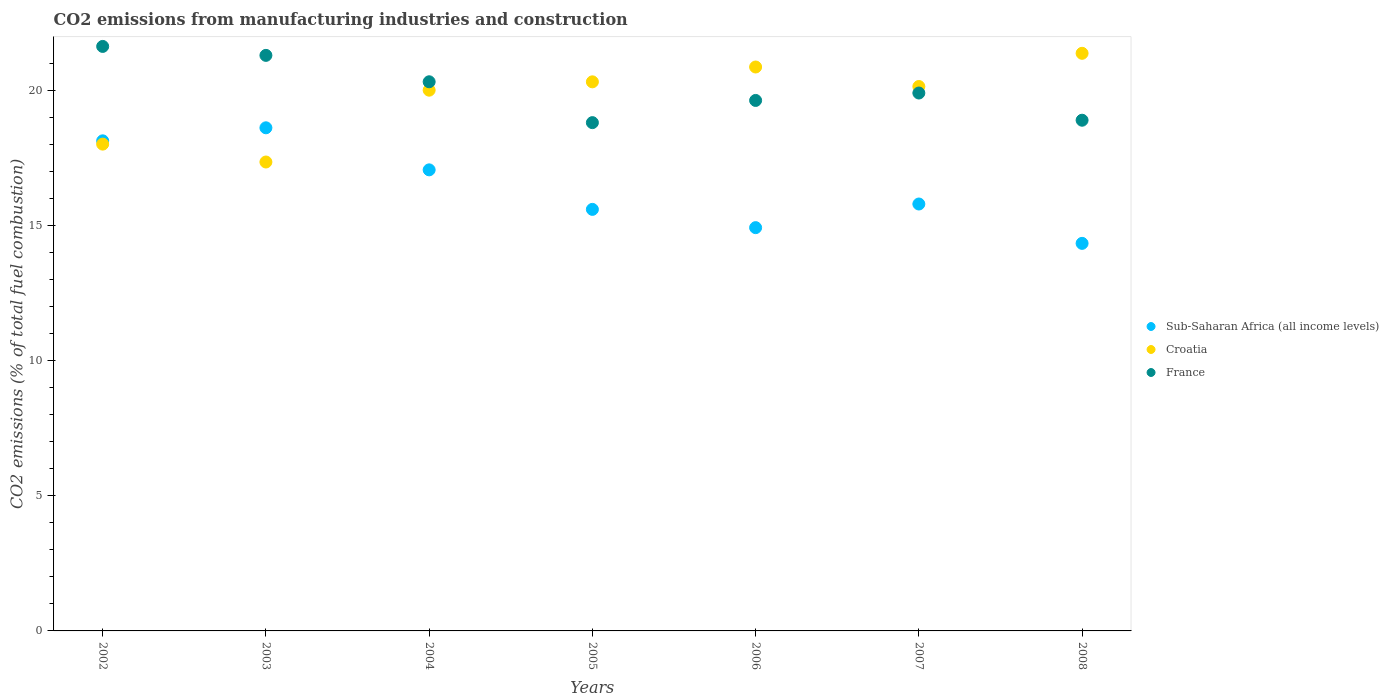Is the number of dotlines equal to the number of legend labels?
Ensure brevity in your answer.  Yes. What is the amount of CO2 emitted in France in 2004?
Your answer should be very brief. 20.31. Across all years, what is the maximum amount of CO2 emitted in France?
Offer a very short reply. 21.62. Across all years, what is the minimum amount of CO2 emitted in Croatia?
Make the answer very short. 17.34. In which year was the amount of CO2 emitted in Croatia maximum?
Offer a very short reply. 2008. In which year was the amount of CO2 emitted in France minimum?
Provide a short and direct response. 2005. What is the total amount of CO2 emitted in Croatia in the graph?
Provide a succinct answer. 138.01. What is the difference between the amount of CO2 emitted in Croatia in 2002 and that in 2007?
Offer a terse response. -2.13. What is the difference between the amount of CO2 emitted in France in 2006 and the amount of CO2 emitted in Sub-Saharan Africa (all income levels) in 2004?
Give a very brief answer. 2.57. What is the average amount of CO2 emitted in France per year?
Offer a terse response. 20.06. In the year 2006, what is the difference between the amount of CO2 emitted in Sub-Saharan Africa (all income levels) and amount of CO2 emitted in Croatia?
Make the answer very short. -5.94. In how many years, is the amount of CO2 emitted in France greater than 8 %?
Make the answer very short. 7. What is the ratio of the amount of CO2 emitted in Croatia in 2002 to that in 2008?
Offer a terse response. 0.84. Is the difference between the amount of CO2 emitted in Sub-Saharan Africa (all income levels) in 2003 and 2004 greater than the difference between the amount of CO2 emitted in Croatia in 2003 and 2004?
Ensure brevity in your answer.  Yes. What is the difference between the highest and the second highest amount of CO2 emitted in Sub-Saharan Africa (all income levels)?
Provide a short and direct response. 0.48. What is the difference between the highest and the lowest amount of CO2 emitted in Sub-Saharan Africa (all income levels)?
Your answer should be compact. 4.27. Does the amount of CO2 emitted in France monotonically increase over the years?
Give a very brief answer. No. Is the amount of CO2 emitted in Sub-Saharan Africa (all income levels) strictly greater than the amount of CO2 emitted in France over the years?
Give a very brief answer. No. How many years are there in the graph?
Offer a very short reply. 7. What is the difference between two consecutive major ticks on the Y-axis?
Give a very brief answer. 5. Does the graph contain any zero values?
Your answer should be compact. No. What is the title of the graph?
Offer a very short reply. CO2 emissions from manufacturing industries and construction. Does "Italy" appear as one of the legend labels in the graph?
Give a very brief answer. No. What is the label or title of the Y-axis?
Provide a short and direct response. CO2 emissions (% of total fuel combustion). What is the CO2 emissions (% of total fuel combustion) in Sub-Saharan Africa (all income levels) in 2002?
Make the answer very short. 18.13. What is the CO2 emissions (% of total fuel combustion) of Croatia in 2002?
Your answer should be very brief. 18.01. What is the CO2 emissions (% of total fuel combustion) of France in 2002?
Offer a very short reply. 21.62. What is the CO2 emissions (% of total fuel combustion) of Sub-Saharan Africa (all income levels) in 2003?
Your response must be concise. 18.61. What is the CO2 emissions (% of total fuel combustion) of Croatia in 2003?
Ensure brevity in your answer.  17.34. What is the CO2 emissions (% of total fuel combustion) of France in 2003?
Your answer should be compact. 21.29. What is the CO2 emissions (% of total fuel combustion) in Sub-Saharan Africa (all income levels) in 2004?
Provide a succinct answer. 17.05. What is the CO2 emissions (% of total fuel combustion) of France in 2004?
Your answer should be compact. 20.31. What is the CO2 emissions (% of total fuel combustion) in Sub-Saharan Africa (all income levels) in 2005?
Make the answer very short. 15.59. What is the CO2 emissions (% of total fuel combustion) in Croatia in 2005?
Your answer should be very brief. 20.31. What is the CO2 emissions (% of total fuel combustion) of France in 2005?
Your response must be concise. 18.8. What is the CO2 emissions (% of total fuel combustion) of Sub-Saharan Africa (all income levels) in 2006?
Your response must be concise. 14.92. What is the CO2 emissions (% of total fuel combustion) of Croatia in 2006?
Keep it short and to the point. 20.86. What is the CO2 emissions (% of total fuel combustion) of France in 2006?
Provide a short and direct response. 19.62. What is the CO2 emissions (% of total fuel combustion) in Sub-Saharan Africa (all income levels) in 2007?
Offer a very short reply. 15.79. What is the CO2 emissions (% of total fuel combustion) in Croatia in 2007?
Offer a very short reply. 20.14. What is the CO2 emissions (% of total fuel combustion) in France in 2007?
Offer a very short reply. 19.89. What is the CO2 emissions (% of total fuel combustion) of Sub-Saharan Africa (all income levels) in 2008?
Your response must be concise. 14.33. What is the CO2 emissions (% of total fuel combustion) of Croatia in 2008?
Provide a succinct answer. 21.36. What is the CO2 emissions (% of total fuel combustion) of France in 2008?
Provide a succinct answer. 18.89. Across all years, what is the maximum CO2 emissions (% of total fuel combustion) of Sub-Saharan Africa (all income levels)?
Keep it short and to the point. 18.61. Across all years, what is the maximum CO2 emissions (% of total fuel combustion) of Croatia?
Ensure brevity in your answer.  21.36. Across all years, what is the maximum CO2 emissions (% of total fuel combustion) of France?
Give a very brief answer. 21.62. Across all years, what is the minimum CO2 emissions (% of total fuel combustion) of Sub-Saharan Africa (all income levels)?
Give a very brief answer. 14.33. Across all years, what is the minimum CO2 emissions (% of total fuel combustion) of Croatia?
Provide a succinct answer. 17.34. Across all years, what is the minimum CO2 emissions (% of total fuel combustion) in France?
Offer a very short reply. 18.8. What is the total CO2 emissions (% of total fuel combustion) in Sub-Saharan Africa (all income levels) in the graph?
Your answer should be very brief. 114.42. What is the total CO2 emissions (% of total fuel combustion) in Croatia in the graph?
Keep it short and to the point. 138.01. What is the total CO2 emissions (% of total fuel combustion) in France in the graph?
Give a very brief answer. 140.42. What is the difference between the CO2 emissions (% of total fuel combustion) of Sub-Saharan Africa (all income levels) in 2002 and that in 2003?
Keep it short and to the point. -0.48. What is the difference between the CO2 emissions (% of total fuel combustion) of Croatia in 2002 and that in 2003?
Your answer should be very brief. 0.66. What is the difference between the CO2 emissions (% of total fuel combustion) in France in 2002 and that in 2003?
Offer a very short reply. 0.33. What is the difference between the CO2 emissions (% of total fuel combustion) in Sub-Saharan Africa (all income levels) in 2002 and that in 2004?
Provide a succinct answer. 1.07. What is the difference between the CO2 emissions (% of total fuel combustion) in Croatia in 2002 and that in 2004?
Keep it short and to the point. -1.99. What is the difference between the CO2 emissions (% of total fuel combustion) in France in 2002 and that in 2004?
Ensure brevity in your answer.  1.31. What is the difference between the CO2 emissions (% of total fuel combustion) of Sub-Saharan Africa (all income levels) in 2002 and that in 2005?
Give a very brief answer. 2.54. What is the difference between the CO2 emissions (% of total fuel combustion) in Croatia in 2002 and that in 2005?
Your answer should be compact. -2.3. What is the difference between the CO2 emissions (% of total fuel combustion) in France in 2002 and that in 2005?
Keep it short and to the point. 2.82. What is the difference between the CO2 emissions (% of total fuel combustion) of Sub-Saharan Africa (all income levels) in 2002 and that in 2006?
Keep it short and to the point. 3.21. What is the difference between the CO2 emissions (% of total fuel combustion) in Croatia in 2002 and that in 2006?
Make the answer very short. -2.85. What is the difference between the CO2 emissions (% of total fuel combustion) of France in 2002 and that in 2006?
Provide a short and direct response. 2. What is the difference between the CO2 emissions (% of total fuel combustion) of Sub-Saharan Africa (all income levels) in 2002 and that in 2007?
Your answer should be compact. 2.34. What is the difference between the CO2 emissions (% of total fuel combustion) of Croatia in 2002 and that in 2007?
Offer a very short reply. -2.13. What is the difference between the CO2 emissions (% of total fuel combustion) of France in 2002 and that in 2007?
Keep it short and to the point. 1.72. What is the difference between the CO2 emissions (% of total fuel combustion) of Sub-Saharan Africa (all income levels) in 2002 and that in 2008?
Your answer should be very brief. 3.79. What is the difference between the CO2 emissions (% of total fuel combustion) of Croatia in 2002 and that in 2008?
Provide a short and direct response. -3.36. What is the difference between the CO2 emissions (% of total fuel combustion) in France in 2002 and that in 2008?
Your response must be concise. 2.73. What is the difference between the CO2 emissions (% of total fuel combustion) in Sub-Saharan Africa (all income levels) in 2003 and that in 2004?
Your answer should be very brief. 1.56. What is the difference between the CO2 emissions (% of total fuel combustion) in Croatia in 2003 and that in 2004?
Make the answer very short. -2.66. What is the difference between the CO2 emissions (% of total fuel combustion) in France in 2003 and that in 2004?
Make the answer very short. 0.98. What is the difference between the CO2 emissions (% of total fuel combustion) of Sub-Saharan Africa (all income levels) in 2003 and that in 2005?
Your answer should be compact. 3.02. What is the difference between the CO2 emissions (% of total fuel combustion) of Croatia in 2003 and that in 2005?
Offer a very short reply. -2.97. What is the difference between the CO2 emissions (% of total fuel combustion) in France in 2003 and that in 2005?
Provide a succinct answer. 2.49. What is the difference between the CO2 emissions (% of total fuel combustion) of Sub-Saharan Africa (all income levels) in 2003 and that in 2006?
Ensure brevity in your answer.  3.69. What is the difference between the CO2 emissions (% of total fuel combustion) in Croatia in 2003 and that in 2006?
Offer a very short reply. -3.51. What is the difference between the CO2 emissions (% of total fuel combustion) of France in 2003 and that in 2006?
Ensure brevity in your answer.  1.67. What is the difference between the CO2 emissions (% of total fuel combustion) of Sub-Saharan Africa (all income levels) in 2003 and that in 2007?
Offer a terse response. 2.82. What is the difference between the CO2 emissions (% of total fuel combustion) of Croatia in 2003 and that in 2007?
Offer a very short reply. -2.79. What is the difference between the CO2 emissions (% of total fuel combustion) in France in 2003 and that in 2007?
Ensure brevity in your answer.  1.39. What is the difference between the CO2 emissions (% of total fuel combustion) in Sub-Saharan Africa (all income levels) in 2003 and that in 2008?
Give a very brief answer. 4.27. What is the difference between the CO2 emissions (% of total fuel combustion) of Croatia in 2003 and that in 2008?
Your answer should be very brief. -4.02. What is the difference between the CO2 emissions (% of total fuel combustion) of France in 2003 and that in 2008?
Give a very brief answer. 2.4. What is the difference between the CO2 emissions (% of total fuel combustion) of Sub-Saharan Africa (all income levels) in 2004 and that in 2005?
Provide a succinct answer. 1.46. What is the difference between the CO2 emissions (% of total fuel combustion) in Croatia in 2004 and that in 2005?
Your answer should be compact. -0.31. What is the difference between the CO2 emissions (% of total fuel combustion) in France in 2004 and that in 2005?
Your answer should be very brief. 1.51. What is the difference between the CO2 emissions (% of total fuel combustion) in Sub-Saharan Africa (all income levels) in 2004 and that in 2006?
Your answer should be compact. 2.14. What is the difference between the CO2 emissions (% of total fuel combustion) in Croatia in 2004 and that in 2006?
Your answer should be very brief. -0.86. What is the difference between the CO2 emissions (% of total fuel combustion) in France in 2004 and that in 2006?
Make the answer very short. 0.69. What is the difference between the CO2 emissions (% of total fuel combustion) in Sub-Saharan Africa (all income levels) in 2004 and that in 2007?
Your response must be concise. 1.26. What is the difference between the CO2 emissions (% of total fuel combustion) in Croatia in 2004 and that in 2007?
Provide a succinct answer. -0.14. What is the difference between the CO2 emissions (% of total fuel combustion) in France in 2004 and that in 2007?
Give a very brief answer. 0.42. What is the difference between the CO2 emissions (% of total fuel combustion) in Sub-Saharan Africa (all income levels) in 2004 and that in 2008?
Ensure brevity in your answer.  2.72. What is the difference between the CO2 emissions (% of total fuel combustion) of Croatia in 2004 and that in 2008?
Provide a succinct answer. -1.36. What is the difference between the CO2 emissions (% of total fuel combustion) in France in 2004 and that in 2008?
Give a very brief answer. 1.42. What is the difference between the CO2 emissions (% of total fuel combustion) of Sub-Saharan Africa (all income levels) in 2005 and that in 2006?
Provide a short and direct response. 0.68. What is the difference between the CO2 emissions (% of total fuel combustion) of Croatia in 2005 and that in 2006?
Provide a succinct answer. -0.55. What is the difference between the CO2 emissions (% of total fuel combustion) in France in 2005 and that in 2006?
Your answer should be very brief. -0.82. What is the difference between the CO2 emissions (% of total fuel combustion) in Sub-Saharan Africa (all income levels) in 2005 and that in 2007?
Offer a very short reply. -0.2. What is the difference between the CO2 emissions (% of total fuel combustion) in Croatia in 2005 and that in 2007?
Your answer should be compact. 0.17. What is the difference between the CO2 emissions (% of total fuel combustion) of France in 2005 and that in 2007?
Ensure brevity in your answer.  -1.1. What is the difference between the CO2 emissions (% of total fuel combustion) of Sub-Saharan Africa (all income levels) in 2005 and that in 2008?
Keep it short and to the point. 1.26. What is the difference between the CO2 emissions (% of total fuel combustion) of Croatia in 2005 and that in 2008?
Make the answer very short. -1.06. What is the difference between the CO2 emissions (% of total fuel combustion) in France in 2005 and that in 2008?
Your answer should be compact. -0.09. What is the difference between the CO2 emissions (% of total fuel combustion) of Sub-Saharan Africa (all income levels) in 2006 and that in 2007?
Offer a very short reply. -0.87. What is the difference between the CO2 emissions (% of total fuel combustion) in Croatia in 2006 and that in 2007?
Provide a short and direct response. 0.72. What is the difference between the CO2 emissions (% of total fuel combustion) in France in 2006 and that in 2007?
Your answer should be very brief. -0.27. What is the difference between the CO2 emissions (% of total fuel combustion) in Sub-Saharan Africa (all income levels) in 2006 and that in 2008?
Offer a very short reply. 0.58. What is the difference between the CO2 emissions (% of total fuel combustion) in Croatia in 2006 and that in 2008?
Give a very brief answer. -0.51. What is the difference between the CO2 emissions (% of total fuel combustion) in France in 2006 and that in 2008?
Your response must be concise. 0.73. What is the difference between the CO2 emissions (% of total fuel combustion) of Sub-Saharan Africa (all income levels) in 2007 and that in 2008?
Provide a succinct answer. 1.46. What is the difference between the CO2 emissions (% of total fuel combustion) in Croatia in 2007 and that in 2008?
Your answer should be compact. -1.23. What is the difference between the CO2 emissions (% of total fuel combustion) of France in 2007 and that in 2008?
Offer a terse response. 1.01. What is the difference between the CO2 emissions (% of total fuel combustion) of Sub-Saharan Africa (all income levels) in 2002 and the CO2 emissions (% of total fuel combustion) of Croatia in 2003?
Your answer should be very brief. 0.78. What is the difference between the CO2 emissions (% of total fuel combustion) in Sub-Saharan Africa (all income levels) in 2002 and the CO2 emissions (% of total fuel combustion) in France in 2003?
Offer a very short reply. -3.16. What is the difference between the CO2 emissions (% of total fuel combustion) in Croatia in 2002 and the CO2 emissions (% of total fuel combustion) in France in 2003?
Your answer should be compact. -3.28. What is the difference between the CO2 emissions (% of total fuel combustion) in Sub-Saharan Africa (all income levels) in 2002 and the CO2 emissions (% of total fuel combustion) in Croatia in 2004?
Your response must be concise. -1.87. What is the difference between the CO2 emissions (% of total fuel combustion) in Sub-Saharan Africa (all income levels) in 2002 and the CO2 emissions (% of total fuel combustion) in France in 2004?
Offer a terse response. -2.18. What is the difference between the CO2 emissions (% of total fuel combustion) in Croatia in 2002 and the CO2 emissions (% of total fuel combustion) in France in 2004?
Offer a very short reply. -2.31. What is the difference between the CO2 emissions (% of total fuel combustion) of Sub-Saharan Africa (all income levels) in 2002 and the CO2 emissions (% of total fuel combustion) of Croatia in 2005?
Give a very brief answer. -2.18. What is the difference between the CO2 emissions (% of total fuel combustion) in Sub-Saharan Africa (all income levels) in 2002 and the CO2 emissions (% of total fuel combustion) in France in 2005?
Your answer should be compact. -0.67. What is the difference between the CO2 emissions (% of total fuel combustion) of Croatia in 2002 and the CO2 emissions (% of total fuel combustion) of France in 2005?
Provide a short and direct response. -0.79. What is the difference between the CO2 emissions (% of total fuel combustion) in Sub-Saharan Africa (all income levels) in 2002 and the CO2 emissions (% of total fuel combustion) in Croatia in 2006?
Offer a very short reply. -2.73. What is the difference between the CO2 emissions (% of total fuel combustion) of Sub-Saharan Africa (all income levels) in 2002 and the CO2 emissions (% of total fuel combustion) of France in 2006?
Provide a succinct answer. -1.49. What is the difference between the CO2 emissions (% of total fuel combustion) of Croatia in 2002 and the CO2 emissions (% of total fuel combustion) of France in 2006?
Offer a terse response. -1.62. What is the difference between the CO2 emissions (% of total fuel combustion) in Sub-Saharan Africa (all income levels) in 2002 and the CO2 emissions (% of total fuel combustion) in Croatia in 2007?
Keep it short and to the point. -2.01. What is the difference between the CO2 emissions (% of total fuel combustion) of Sub-Saharan Africa (all income levels) in 2002 and the CO2 emissions (% of total fuel combustion) of France in 2007?
Keep it short and to the point. -1.77. What is the difference between the CO2 emissions (% of total fuel combustion) of Croatia in 2002 and the CO2 emissions (% of total fuel combustion) of France in 2007?
Your answer should be very brief. -1.89. What is the difference between the CO2 emissions (% of total fuel combustion) in Sub-Saharan Africa (all income levels) in 2002 and the CO2 emissions (% of total fuel combustion) in Croatia in 2008?
Ensure brevity in your answer.  -3.24. What is the difference between the CO2 emissions (% of total fuel combustion) in Sub-Saharan Africa (all income levels) in 2002 and the CO2 emissions (% of total fuel combustion) in France in 2008?
Offer a very short reply. -0.76. What is the difference between the CO2 emissions (% of total fuel combustion) of Croatia in 2002 and the CO2 emissions (% of total fuel combustion) of France in 2008?
Offer a terse response. -0.88. What is the difference between the CO2 emissions (% of total fuel combustion) in Sub-Saharan Africa (all income levels) in 2003 and the CO2 emissions (% of total fuel combustion) in Croatia in 2004?
Provide a succinct answer. -1.39. What is the difference between the CO2 emissions (% of total fuel combustion) of Sub-Saharan Africa (all income levels) in 2003 and the CO2 emissions (% of total fuel combustion) of France in 2004?
Offer a terse response. -1.7. What is the difference between the CO2 emissions (% of total fuel combustion) in Croatia in 2003 and the CO2 emissions (% of total fuel combustion) in France in 2004?
Make the answer very short. -2.97. What is the difference between the CO2 emissions (% of total fuel combustion) of Sub-Saharan Africa (all income levels) in 2003 and the CO2 emissions (% of total fuel combustion) of France in 2005?
Make the answer very short. -0.19. What is the difference between the CO2 emissions (% of total fuel combustion) in Croatia in 2003 and the CO2 emissions (% of total fuel combustion) in France in 2005?
Give a very brief answer. -1.46. What is the difference between the CO2 emissions (% of total fuel combustion) in Sub-Saharan Africa (all income levels) in 2003 and the CO2 emissions (% of total fuel combustion) in Croatia in 2006?
Keep it short and to the point. -2.25. What is the difference between the CO2 emissions (% of total fuel combustion) in Sub-Saharan Africa (all income levels) in 2003 and the CO2 emissions (% of total fuel combustion) in France in 2006?
Ensure brevity in your answer.  -1.01. What is the difference between the CO2 emissions (% of total fuel combustion) in Croatia in 2003 and the CO2 emissions (% of total fuel combustion) in France in 2006?
Your response must be concise. -2.28. What is the difference between the CO2 emissions (% of total fuel combustion) of Sub-Saharan Africa (all income levels) in 2003 and the CO2 emissions (% of total fuel combustion) of Croatia in 2007?
Provide a succinct answer. -1.53. What is the difference between the CO2 emissions (% of total fuel combustion) of Sub-Saharan Africa (all income levels) in 2003 and the CO2 emissions (% of total fuel combustion) of France in 2007?
Provide a short and direct response. -1.29. What is the difference between the CO2 emissions (% of total fuel combustion) in Croatia in 2003 and the CO2 emissions (% of total fuel combustion) in France in 2007?
Provide a succinct answer. -2.55. What is the difference between the CO2 emissions (% of total fuel combustion) in Sub-Saharan Africa (all income levels) in 2003 and the CO2 emissions (% of total fuel combustion) in Croatia in 2008?
Keep it short and to the point. -2.76. What is the difference between the CO2 emissions (% of total fuel combustion) in Sub-Saharan Africa (all income levels) in 2003 and the CO2 emissions (% of total fuel combustion) in France in 2008?
Your response must be concise. -0.28. What is the difference between the CO2 emissions (% of total fuel combustion) in Croatia in 2003 and the CO2 emissions (% of total fuel combustion) in France in 2008?
Your answer should be compact. -1.55. What is the difference between the CO2 emissions (% of total fuel combustion) in Sub-Saharan Africa (all income levels) in 2004 and the CO2 emissions (% of total fuel combustion) in Croatia in 2005?
Ensure brevity in your answer.  -3.26. What is the difference between the CO2 emissions (% of total fuel combustion) of Sub-Saharan Africa (all income levels) in 2004 and the CO2 emissions (% of total fuel combustion) of France in 2005?
Give a very brief answer. -1.75. What is the difference between the CO2 emissions (% of total fuel combustion) in Croatia in 2004 and the CO2 emissions (% of total fuel combustion) in France in 2005?
Provide a succinct answer. 1.2. What is the difference between the CO2 emissions (% of total fuel combustion) in Sub-Saharan Africa (all income levels) in 2004 and the CO2 emissions (% of total fuel combustion) in Croatia in 2006?
Ensure brevity in your answer.  -3.8. What is the difference between the CO2 emissions (% of total fuel combustion) of Sub-Saharan Africa (all income levels) in 2004 and the CO2 emissions (% of total fuel combustion) of France in 2006?
Give a very brief answer. -2.57. What is the difference between the CO2 emissions (% of total fuel combustion) of Croatia in 2004 and the CO2 emissions (% of total fuel combustion) of France in 2006?
Your response must be concise. 0.38. What is the difference between the CO2 emissions (% of total fuel combustion) in Sub-Saharan Africa (all income levels) in 2004 and the CO2 emissions (% of total fuel combustion) in Croatia in 2007?
Offer a terse response. -3.08. What is the difference between the CO2 emissions (% of total fuel combustion) of Sub-Saharan Africa (all income levels) in 2004 and the CO2 emissions (% of total fuel combustion) of France in 2007?
Offer a terse response. -2.84. What is the difference between the CO2 emissions (% of total fuel combustion) of Croatia in 2004 and the CO2 emissions (% of total fuel combustion) of France in 2007?
Ensure brevity in your answer.  0.11. What is the difference between the CO2 emissions (% of total fuel combustion) in Sub-Saharan Africa (all income levels) in 2004 and the CO2 emissions (% of total fuel combustion) in Croatia in 2008?
Provide a short and direct response. -4.31. What is the difference between the CO2 emissions (% of total fuel combustion) of Sub-Saharan Africa (all income levels) in 2004 and the CO2 emissions (% of total fuel combustion) of France in 2008?
Offer a very short reply. -1.84. What is the difference between the CO2 emissions (% of total fuel combustion) of Croatia in 2004 and the CO2 emissions (% of total fuel combustion) of France in 2008?
Keep it short and to the point. 1.11. What is the difference between the CO2 emissions (% of total fuel combustion) in Sub-Saharan Africa (all income levels) in 2005 and the CO2 emissions (% of total fuel combustion) in Croatia in 2006?
Your answer should be compact. -5.27. What is the difference between the CO2 emissions (% of total fuel combustion) in Sub-Saharan Africa (all income levels) in 2005 and the CO2 emissions (% of total fuel combustion) in France in 2006?
Offer a very short reply. -4.03. What is the difference between the CO2 emissions (% of total fuel combustion) of Croatia in 2005 and the CO2 emissions (% of total fuel combustion) of France in 2006?
Offer a terse response. 0.69. What is the difference between the CO2 emissions (% of total fuel combustion) in Sub-Saharan Africa (all income levels) in 2005 and the CO2 emissions (% of total fuel combustion) in Croatia in 2007?
Keep it short and to the point. -4.54. What is the difference between the CO2 emissions (% of total fuel combustion) in Sub-Saharan Africa (all income levels) in 2005 and the CO2 emissions (% of total fuel combustion) in France in 2007?
Ensure brevity in your answer.  -4.3. What is the difference between the CO2 emissions (% of total fuel combustion) in Croatia in 2005 and the CO2 emissions (% of total fuel combustion) in France in 2007?
Offer a terse response. 0.41. What is the difference between the CO2 emissions (% of total fuel combustion) of Sub-Saharan Africa (all income levels) in 2005 and the CO2 emissions (% of total fuel combustion) of Croatia in 2008?
Give a very brief answer. -5.77. What is the difference between the CO2 emissions (% of total fuel combustion) in Sub-Saharan Africa (all income levels) in 2005 and the CO2 emissions (% of total fuel combustion) in France in 2008?
Your answer should be compact. -3.3. What is the difference between the CO2 emissions (% of total fuel combustion) of Croatia in 2005 and the CO2 emissions (% of total fuel combustion) of France in 2008?
Give a very brief answer. 1.42. What is the difference between the CO2 emissions (% of total fuel combustion) of Sub-Saharan Africa (all income levels) in 2006 and the CO2 emissions (% of total fuel combustion) of Croatia in 2007?
Ensure brevity in your answer.  -5.22. What is the difference between the CO2 emissions (% of total fuel combustion) in Sub-Saharan Africa (all income levels) in 2006 and the CO2 emissions (% of total fuel combustion) in France in 2007?
Ensure brevity in your answer.  -4.98. What is the difference between the CO2 emissions (% of total fuel combustion) of Croatia in 2006 and the CO2 emissions (% of total fuel combustion) of France in 2007?
Keep it short and to the point. 0.96. What is the difference between the CO2 emissions (% of total fuel combustion) in Sub-Saharan Africa (all income levels) in 2006 and the CO2 emissions (% of total fuel combustion) in Croatia in 2008?
Make the answer very short. -6.45. What is the difference between the CO2 emissions (% of total fuel combustion) in Sub-Saharan Africa (all income levels) in 2006 and the CO2 emissions (% of total fuel combustion) in France in 2008?
Offer a very short reply. -3.97. What is the difference between the CO2 emissions (% of total fuel combustion) of Croatia in 2006 and the CO2 emissions (% of total fuel combustion) of France in 2008?
Offer a very short reply. 1.97. What is the difference between the CO2 emissions (% of total fuel combustion) in Sub-Saharan Africa (all income levels) in 2007 and the CO2 emissions (% of total fuel combustion) in Croatia in 2008?
Ensure brevity in your answer.  -5.57. What is the difference between the CO2 emissions (% of total fuel combustion) in Sub-Saharan Africa (all income levels) in 2007 and the CO2 emissions (% of total fuel combustion) in France in 2008?
Offer a very short reply. -3.1. What is the difference between the CO2 emissions (% of total fuel combustion) of Croatia in 2007 and the CO2 emissions (% of total fuel combustion) of France in 2008?
Provide a short and direct response. 1.25. What is the average CO2 emissions (% of total fuel combustion) of Sub-Saharan Africa (all income levels) per year?
Your answer should be compact. 16.35. What is the average CO2 emissions (% of total fuel combustion) in Croatia per year?
Provide a short and direct response. 19.72. What is the average CO2 emissions (% of total fuel combustion) of France per year?
Provide a short and direct response. 20.06. In the year 2002, what is the difference between the CO2 emissions (% of total fuel combustion) of Sub-Saharan Africa (all income levels) and CO2 emissions (% of total fuel combustion) of Croatia?
Offer a very short reply. 0.12. In the year 2002, what is the difference between the CO2 emissions (% of total fuel combustion) in Sub-Saharan Africa (all income levels) and CO2 emissions (% of total fuel combustion) in France?
Make the answer very short. -3.49. In the year 2002, what is the difference between the CO2 emissions (% of total fuel combustion) in Croatia and CO2 emissions (% of total fuel combustion) in France?
Give a very brief answer. -3.61. In the year 2003, what is the difference between the CO2 emissions (% of total fuel combustion) of Sub-Saharan Africa (all income levels) and CO2 emissions (% of total fuel combustion) of Croatia?
Your answer should be very brief. 1.27. In the year 2003, what is the difference between the CO2 emissions (% of total fuel combustion) in Sub-Saharan Africa (all income levels) and CO2 emissions (% of total fuel combustion) in France?
Make the answer very short. -2.68. In the year 2003, what is the difference between the CO2 emissions (% of total fuel combustion) of Croatia and CO2 emissions (% of total fuel combustion) of France?
Provide a succinct answer. -3.94. In the year 2004, what is the difference between the CO2 emissions (% of total fuel combustion) in Sub-Saharan Africa (all income levels) and CO2 emissions (% of total fuel combustion) in Croatia?
Your answer should be compact. -2.95. In the year 2004, what is the difference between the CO2 emissions (% of total fuel combustion) in Sub-Saharan Africa (all income levels) and CO2 emissions (% of total fuel combustion) in France?
Ensure brevity in your answer.  -3.26. In the year 2004, what is the difference between the CO2 emissions (% of total fuel combustion) in Croatia and CO2 emissions (% of total fuel combustion) in France?
Make the answer very short. -0.31. In the year 2005, what is the difference between the CO2 emissions (% of total fuel combustion) of Sub-Saharan Africa (all income levels) and CO2 emissions (% of total fuel combustion) of Croatia?
Provide a succinct answer. -4.72. In the year 2005, what is the difference between the CO2 emissions (% of total fuel combustion) of Sub-Saharan Africa (all income levels) and CO2 emissions (% of total fuel combustion) of France?
Offer a very short reply. -3.21. In the year 2005, what is the difference between the CO2 emissions (% of total fuel combustion) in Croatia and CO2 emissions (% of total fuel combustion) in France?
Offer a very short reply. 1.51. In the year 2006, what is the difference between the CO2 emissions (% of total fuel combustion) in Sub-Saharan Africa (all income levels) and CO2 emissions (% of total fuel combustion) in Croatia?
Make the answer very short. -5.94. In the year 2006, what is the difference between the CO2 emissions (% of total fuel combustion) in Sub-Saharan Africa (all income levels) and CO2 emissions (% of total fuel combustion) in France?
Ensure brevity in your answer.  -4.71. In the year 2006, what is the difference between the CO2 emissions (% of total fuel combustion) in Croatia and CO2 emissions (% of total fuel combustion) in France?
Your response must be concise. 1.24. In the year 2007, what is the difference between the CO2 emissions (% of total fuel combustion) in Sub-Saharan Africa (all income levels) and CO2 emissions (% of total fuel combustion) in Croatia?
Your response must be concise. -4.35. In the year 2007, what is the difference between the CO2 emissions (% of total fuel combustion) in Sub-Saharan Africa (all income levels) and CO2 emissions (% of total fuel combustion) in France?
Offer a very short reply. -4.1. In the year 2007, what is the difference between the CO2 emissions (% of total fuel combustion) of Croatia and CO2 emissions (% of total fuel combustion) of France?
Your answer should be compact. 0.24. In the year 2008, what is the difference between the CO2 emissions (% of total fuel combustion) in Sub-Saharan Africa (all income levels) and CO2 emissions (% of total fuel combustion) in Croatia?
Your answer should be very brief. -7.03. In the year 2008, what is the difference between the CO2 emissions (% of total fuel combustion) in Sub-Saharan Africa (all income levels) and CO2 emissions (% of total fuel combustion) in France?
Make the answer very short. -4.55. In the year 2008, what is the difference between the CO2 emissions (% of total fuel combustion) in Croatia and CO2 emissions (% of total fuel combustion) in France?
Provide a succinct answer. 2.47. What is the ratio of the CO2 emissions (% of total fuel combustion) in Sub-Saharan Africa (all income levels) in 2002 to that in 2003?
Offer a terse response. 0.97. What is the ratio of the CO2 emissions (% of total fuel combustion) in Croatia in 2002 to that in 2003?
Your answer should be very brief. 1.04. What is the ratio of the CO2 emissions (% of total fuel combustion) of France in 2002 to that in 2003?
Your answer should be very brief. 1.02. What is the ratio of the CO2 emissions (% of total fuel combustion) of Sub-Saharan Africa (all income levels) in 2002 to that in 2004?
Your answer should be very brief. 1.06. What is the ratio of the CO2 emissions (% of total fuel combustion) of Croatia in 2002 to that in 2004?
Provide a succinct answer. 0.9. What is the ratio of the CO2 emissions (% of total fuel combustion) of France in 2002 to that in 2004?
Provide a short and direct response. 1.06. What is the ratio of the CO2 emissions (% of total fuel combustion) of Sub-Saharan Africa (all income levels) in 2002 to that in 2005?
Offer a terse response. 1.16. What is the ratio of the CO2 emissions (% of total fuel combustion) in Croatia in 2002 to that in 2005?
Your answer should be compact. 0.89. What is the ratio of the CO2 emissions (% of total fuel combustion) of France in 2002 to that in 2005?
Provide a succinct answer. 1.15. What is the ratio of the CO2 emissions (% of total fuel combustion) of Sub-Saharan Africa (all income levels) in 2002 to that in 2006?
Ensure brevity in your answer.  1.22. What is the ratio of the CO2 emissions (% of total fuel combustion) in Croatia in 2002 to that in 2006?
Provide a short and direct response. 0.86. What is the ratio of the CO2 emissions (% of total fuel combustion) in France in 2002 to that in 2006?
Offer a very short reply. 1.1. What is the ratio of the CO2 emissions (% of total fuel combustion) of Sub-Saharan Africa (all income levels) in 2002 to that in 2007?
Your answer should be very brief. 1.15. What is the ratio of the CO2 emissions (% of total fuel combustion) of Croatia in 2002 to that in 2007?
Your answer should be very brief. 0.89. What is the ratio of the CO2 emissions (% of total fuel combustion) of France in 2002 to that in 2007?
Provide a short and direct response. 1.09. What is the ratio of the CO2 emissions (% of total fuel combustion) in Sub-Saharan Africa (all income levels) in 2002 to that in 2008?
Your response must be concise. 1.26. What is the ratio of the CO2 emissions (% of total fuel combustion) of Croatia in 2002 to that in 2008?
Give a very brief answer. 0.84. What is the ratio of the CO2 emissions (% of total fuel combustion) of France in 2002 to that in 2008?
Ensure brevity in your answer.  1.14. What is the ratio of the CO2 emissions (% of total fuel combustion) of Sub-Saharan Africa (all income levels) in 2003 to that in 2004?
Offer a terse response. 1.09. What is the ratio of the CO2 emissions (% of total fuel combustion) of Croatia in 2003 to that in 2004?
Offer a terse response. 0.87. What is the ratio of the CO2 emissions (% of total fuel combustion) of France in 2003 to that in 2004?
Keep it short and to the point. 1.05. What is the ratio of the CO2 emissions (% of total fuel combustion) in Sub-Saharan Africa (all income levels) in 2003 to that in 2005?
Your answer should be very brief. 1.19. What is the ratio of the CO2 emissions (% of total fuel combustion) of Croatia in 2003 to that in 2005?
Your answer should be very brief. 0.85. What is the ratio of the CO2 emissions (% of total fuel combustion) in France in 2003 to that in 2005?
Keep it short and to the point. 1.13. What is the ratio of the CO2 emissions (% of total fuel combustion) in Sub-Saharan Africa (all income levels) in 2003 to that in 2006?
Offer a very short reply. 1.25. What is the ratio of the CO2 emissions (% of total fuel combustion) of Croatia in 2003 to that in 2006?
Provide a short and direct response. 0.83. What is the ratio of the CO2 emissions (% of total fuel combustion) in France in 2003 to that in 2006?
Keep it short and to the point. 1.08. What is the ratio of the CO2 emissions (% of total fuel combustion) in Sub-Saharan Africa (all income levels) in 2003 to that in 2007?
Provide a short and direct response. 1.18. What is the ratio of the CO2 emissions (% of total fuel combustion) of Croatia in 2003 to that in 2007?
Keep it short and to the point. 0.86. What is the ratio of the CO2 emissions (% of total fuel combustion) in France in 2003 to that in 2007?
Ensure brevity in your answer.  1.07. What is the ratio of the CO2 emissions (% of total fuel combustion) in Sub-Saharan Africa (all income levels) in 2003 to that in 2008?
Ensure brevity in your answer.  1.3. What is the ratio of the CO2 emissions (% of total fuel combustion) of Croatia in 2003 to that in 2008?
Provide a succinct answer. 0.81. What is the ratio of the CO2 emissions (% of total fuel combustion) of France in 2003 to that in 2008?
Your response must be concise. 1.13. What is the ratio of the CO2 emissions (% of total fuel combustion) of Sub-Saharan Africa (all income levels) in 2004 to that in 2005?
Keep it short and to the point. 1.09. What is the ratio of the CO2 emissions (% of total fuel combustion) of France in 2004 to that in 2005?
Provide a short and direct response. 1.08. What is the ratio of the CO2 emissions (% of total fuel combustion) of Sub-Saharan Africa (all income levels) in 2004 to that in 2006?
Your response must be concise. 1.14. What is the ratio of the CO2 emissions (% of total fuel combustion) of Croatia in 2004 to that in 2006?
Keep it short and to the point. 0.96. What is the ratio of the CO2 emissions (% of total fuel combustion) of France in 2004 to that in 2006?
Offer a very short reply. 1.04. What is the ratio of the CO2 emissions (% of total fuel combustion) in France in 2004 to that in 2007?
Give a very brief answer. 1.02. What is the ratio of the CO2 emissions (% of total fuel combustion) in Sub-Saharan Africa (all income levels) in 2004 to that in 2008?
Your answer should be very brief. 1.19. What is the ratio of the CO2 emissions (% of total fuel combustion) of Croatia in 2004 to that in 2008?
Your answer should be compact. 0.94. What is the ratio of the CO2 emissions (% of total fuel combustion) in France in 2004 to that in 2008?
Your response must be concise. 1.08. What is the ratio of the CO2 emissions (% of total fuel combustion) of Sub-Saharan Africa (all income levels) in 2005 to that in 2006?
Provide a short and direct response. 1.05. What is the ratio of the CO2 emissions (% of total fuel combustion) of Croatia in 2005 to that in 2006?
Provide a short and direct response. 0.97. What is the ratio of the CO2 emissions (% of total fuel combustion) in France in 2005 to that in 2006?
Provide a succinct answer. 0.96. What is the ratio of the CO2 emissions (% of total fuel combustion) in Sub-Saharan Africa (all income levels) in 2005 to that in 2007?
Ensure brevity in your answer.  0.99. What is the ratio of the CO2 emissions (% of total fuel combustion) of Croatia in 2005 to that in 2007?
Keep it short and to the point. 1.01. What is the ratio of the CO2 emissions (% of total fuel combustion) in France in 2005 to that in 2007?
Offer a terse response. 0.94. What is the ratio of the CO2 emissions (% of total fuel combustion) of Sub-Saharan Africa (all income levels) in 2005 to that in 2008?
Provide a succinct answer. 1.09. What is the ratio of the CO2 emissions (% of total fuel combustion) in Croatia in 2005 to that in 2008?
Give a very brief answer. 0.95. What is the ratio of the CO2 emissions (% of total fuel combustion) of Sub-Saharan Africa (all income levels) in 2006 to that in 2007?
Offer a very short reply. 0.94. What is the ratio of the CO2 emissions (% of total fuel combustion) in Croatia in 2006 to that in 2007?
Offer a terse response. 1.04. What is the ratio of the CO2 emissions (% of total fuel combustion) in France in 2006 to that in 2007?
Provide a succinct answer. 0.99. What is the ratio of the CO2 emissions (% of total fuel combustion) in Sub-Saharan Africa (all income levels) in 2006 to that in 2008?
Offer a very short reply. 1.04. What is the ratio of the CO2 emissions (% of total fuel combustion) of Croatia in 2006 to that in 2008?
Provide a short and direct response. 0.98. What is the ratio of the CO2 emissions (% of total fuel combustion) of France in 2006 to that in 2008?
Your answer should be compact. 1.04. What is the ratio of the CO2 emissions (% of total fuel combustion) in Sub-Saharan Africa (all income levels) in 2007 to that in 2008?
Ensure brevity in your answer.  1.1. What is the ratio of the CO2 emissions (% of total fuel combustion) of Croatia in 2007 to that in 2008?
Make the answer very short. 0.94. What is the ratio of the CO2 emissions (% of total fuel combustion) in France in 2007 to that in 2008?
Keep it short and to the point. 1.05. What is the difference between the highest and the second highest CO2 emissions (% of total fuel combustion) of Sub-Saharan Africa (all income levels)?
Your response must be concise. 0.48. What is the difference between the highest and the second highest CO2 emissions (% of total fuel combustion) in Croatia?
Provide a short and direct response. 0.51. What is the difference between the highest and the second highest CO2 emissions (% of total fuel combustion) of France?
Provide a succinct answer. 0.33. What is the difference between the highest and the lowest CO2 emissions (% of total fuel combustion) of Sub-Saharan Africa (all income levels)?
Your response must be concise. 4.27. What is the difference between the highest and the lowest CO2 emissions (% of total fuel combustion) of Croatia?
Your answer should be very brief. 4.02. What is the difference between the highest and the lowest CO2 emissions (% of total fuel combustion) in France?
Make the answer very short. 2.82. 